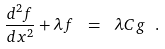Convert formula to latex. <formula><loc_0><loc_0><loc_500><loc_500>\frac { d ^ { 2 } f } { d x ^ { 2 } } + \lambda f \ = \ \lambda C g \ .</formula> 